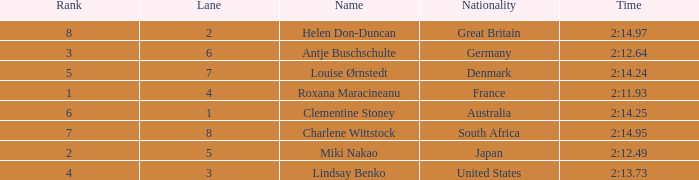What is the number of lane with a rank more than 2 for louise ørnstedt? 1.0. 